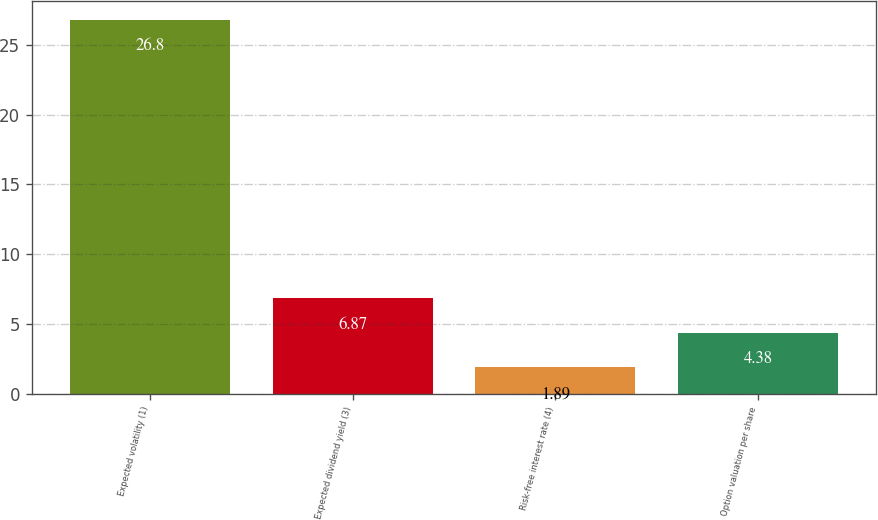Convert chart to OTSL. <chart><loc_0><loc_0><loc_500><loc_500><bar_chart><fcel>Expected volatility (1)<fcel>Expected dividend yield (3)<fcel>Risk-free interest rate (4)<fcel>Option valuation per share<nl><fcel>26.8<fcel>6.87<fcel>1.89<fcel>4.38<nl></chart> 